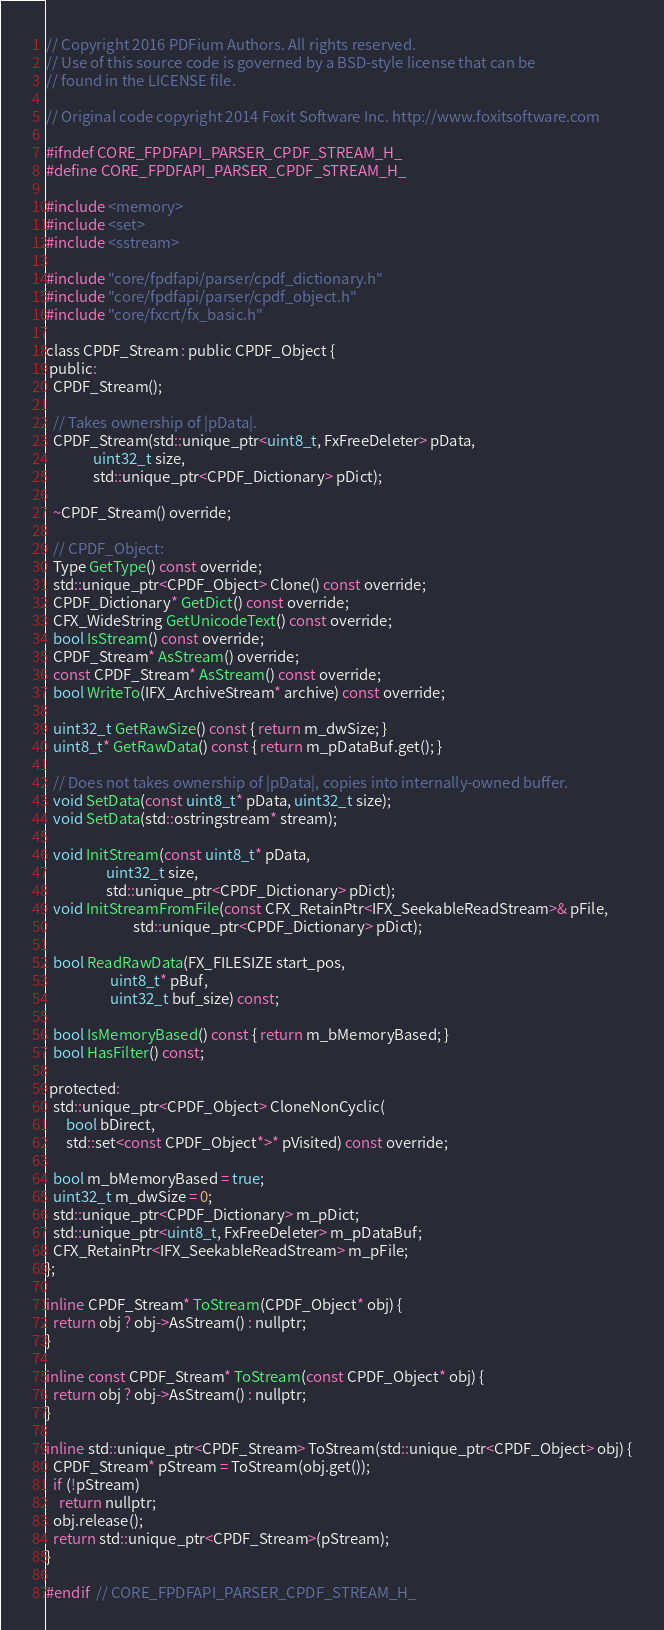<code> <loc_0><loc_0><loc_500><loc_500><_C_>// Copyright 2016 PDFium Authors. All rights reserved.
// Use of this source code is governed by a BSD-style license that can be
// found in the LICENSE file.

// Original code copyright 2014 Foxit Software Inc. http://www.foxitsoftware.com

#ifndef CORE_FPDFAPI_PARSER_CPDF_STREAM_H_
#define CORE_FPDFAPI_PARSER_CPDF_STREAM_H_

#include <memory>
#include <set>
#include <sstream>

#include "core/fpdfapi/parser/cpdf_dictionary.h"
#include "core/fpdfapi/parser/cpdf_object.h"
#include "core/fxcrt/fx_basic.h"

class CPDF_Stream : public CPDF_Object {
 public:
  CPDF_Stream();

  // Takes ownership of |pData|.
  CPDF_Stream(std::unique_ptr<uint8_t, FxFreeDeleter> pData,
              uint32_t size,
              std::unique_ptr<CPDF_Dictionary> pDict);

  ~CPDF_Stream() override;

  // CPDF_Object:
  Type GetType() const override;
  std::unique_ptr<CPDF_Object> Clone() const override;
  CPDF_Dictionary* GetDict() const override;
  CFX_WideString GetUnicodeText() const override;
  bool IsStream() const override;
  CPDF_Stream* AsStream() override;
  const CPDF_Stream* AsStream() const override;
  bool WriteTo(IFX_ArchiveStream* archive) const override;

  uint32_t GetRawSize() const { return m_dwSize; }
  uint8_t* GetRawData() const { return m_pDataBuf.get(); }

  // Does not takes ownership of |pData|, copies into internally-owned buffer.
  void SetData(const uint8_t* pData, uint32_t size);
  void SetData(std::ostringstream* stream);

  void InitStream(const uint8_t* pData,
                  uint32_t size,
                  std::unique_ptr<CPDF_Dictionary> pDict);
  void InitStreamFromFile(const CFX_RetainPtr<IFX_SeekableReadStream>& pFile,
                          std::unique_ptr<CPDF_Dictionary> pDict);

  bool ReadRawData(FX_FILESIZE start_pos,
                   uint8_t* pBuf,
                   uint32_t buf_size) const;

  bool IsMemoryBased() const { return m_bMemoryBased; }
  bool HasFilter() const;

 protected:
  std::unique_ptr<CPDF_Object> CloneNonCyclic(
      bool bDirect,
      std::set<const CPDF_Object*>* pVisited) const override;

  bool m_bMemoryBased = true;
  uint32_t m_dwSize = 0;
  std::unique_ptr<CPDF_Dictionary> m_pDict;
  std::unique_ptr<uint8_t, FxFreeDeleter> m_pDataBuf;
  CFX_RetainPtr<IFX_SeekableReadStream> m_pFile;
};

inline CPDF_Stream* ToStream(CPDF_Object* obj) {
  return obj ? obj->AsStream() : nullptr;
}

inline const CPDF_Stream* ToStream(const CPDF_Object* obj) {
  return obj ? obj->AsStream() : nullptr;
}

inline std::unique_ptr<CPDF_Stream> ToStream(std::unique_ptr<CPDF_Object> obj) {
  CPDF_Stream* pStream = ToStream(obj.get());
  if (!pStream)
    return nullptr;
  obj.release();
  return std::unique_ptr<CPDF_Stream>(pStream);
}

#endif  // CORE_FPDFAPI_PARSER_CPDF_STREAM_H_
</code> 